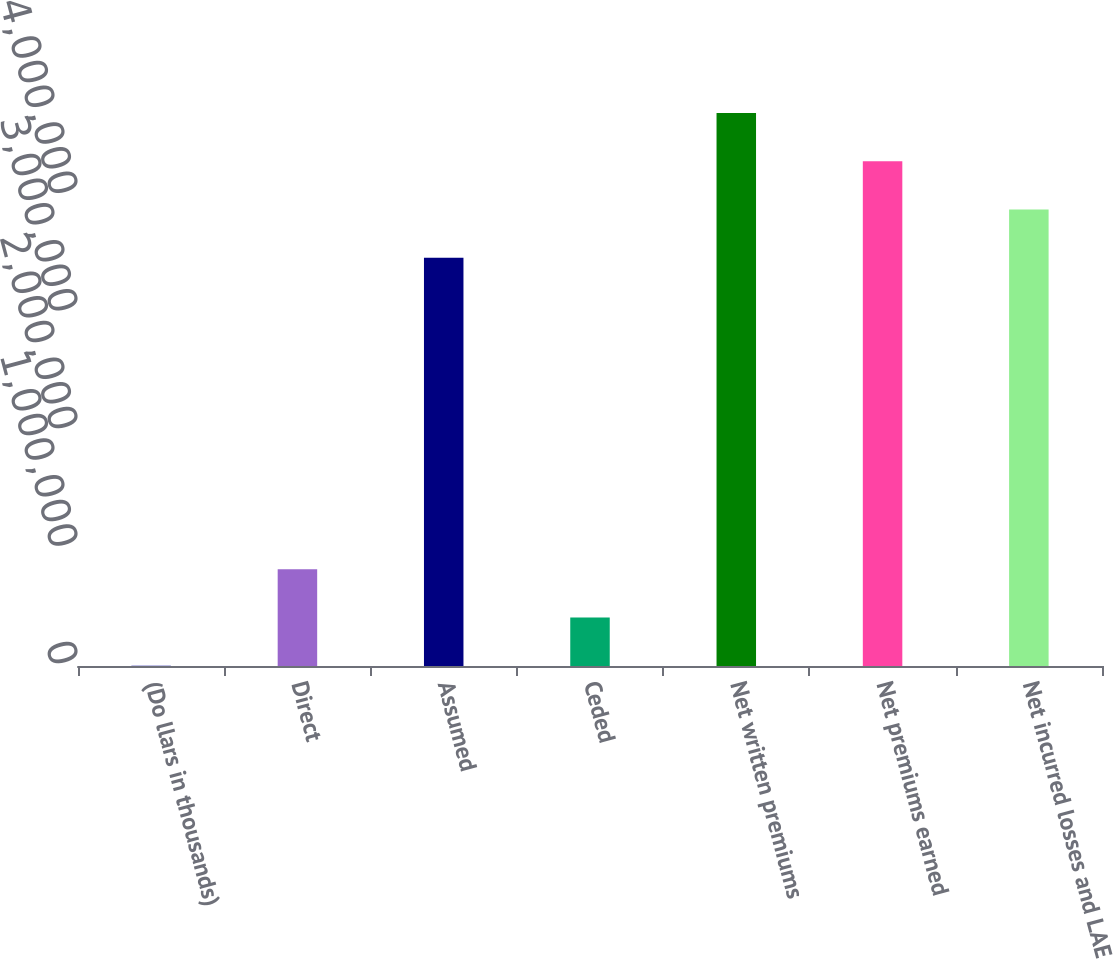Convert chart to OTSL. <chart><loc_0><loc_0><loc_500><loc_500><bar_chart><fcel>(Do llars in thousands)<fcel>Direct<fcel>Assumed<fcel>Ceded<fcel>Net written premiums<fcel>Net premiums earned<fcel>Net incurred losses and LAE<nl><fcel>2011<fcel>823389<fcel>3.47109e+06<fcel>412700<fcel>4.70315e+06<fcel>4.29246e+06<fcel>3.88178e+06<nl></chart> 